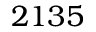Convert formula to latex. <formula><loc_0><loc_0><loc_500><loc_500>2 1 3 5</formula> 